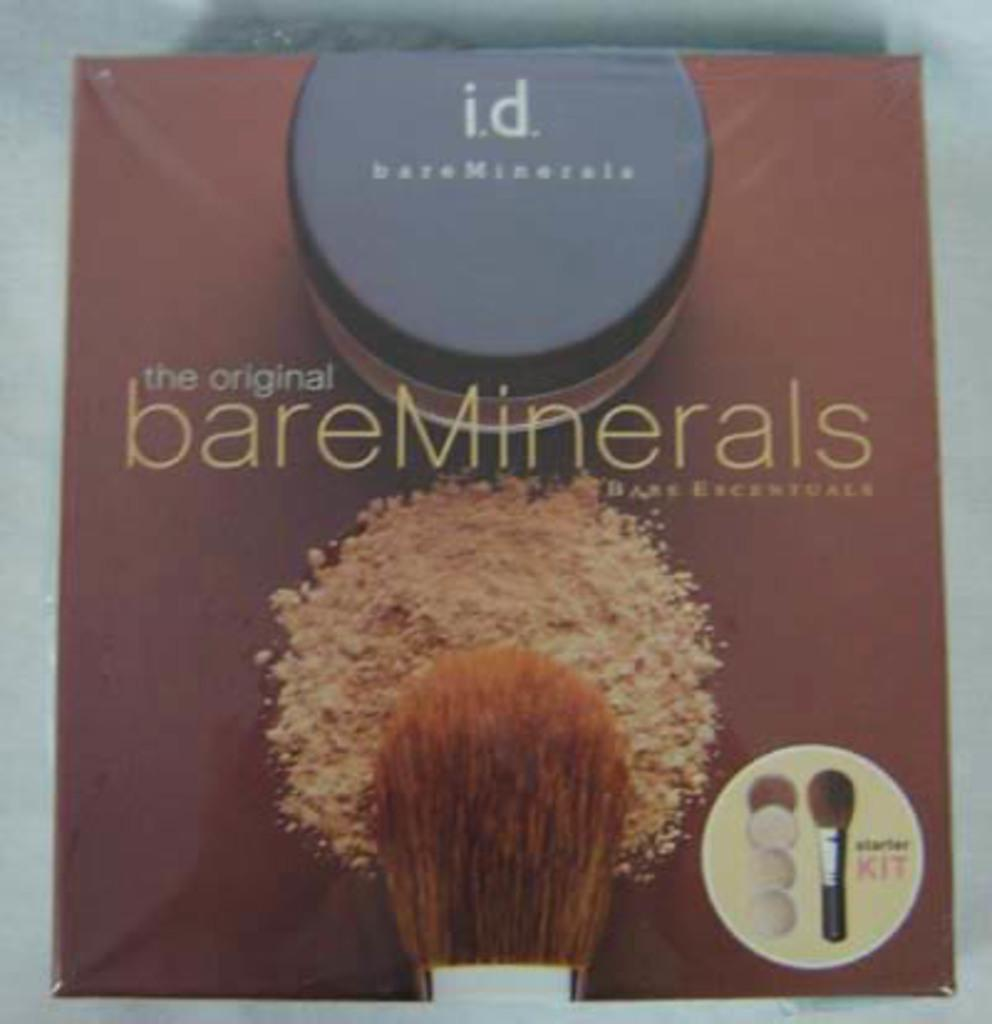What object is in the image that is box-shaped? There is a box in the image. What color is the box? The box is brown in color. What items are on the box? Makeup brushes are present on the box. What can be found on the box besides the makeup brushes? There is text on the box. On what surface is the box placed? The box is placed on a white surface. What type of star can be seen shining brightly on the box in the image? There is no star present on the box in the image. What type of thread is used to hold the makeup brushes together on the box? There is no thread visible on the box in the image. 